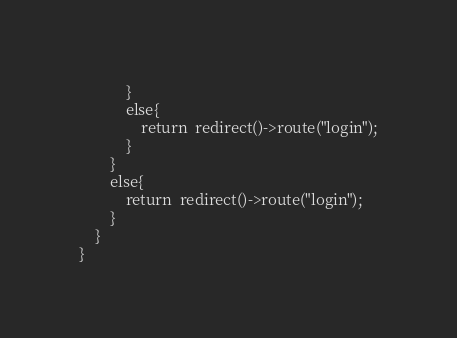<code> <loc_0><loc_0><loc_500><loc_500><_PHP_>            }
            else{
                return  redirect()->route("login");
            }
        }
        else{
            return  redirect()->route("login");
        }
    }
}
</code> 